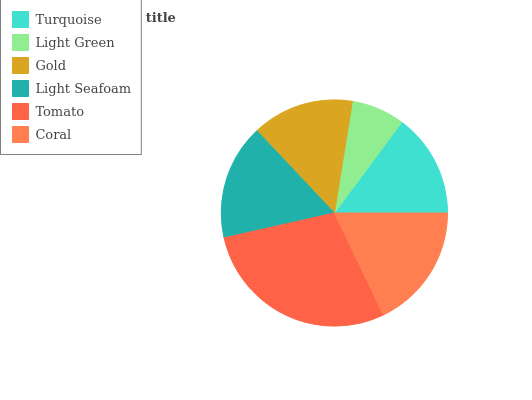Is Light Green the minimum?
Answer yes or no. Yes. Is Tomato the maximum?
Answer yes or no. Yes. Is Gold the minimum?
Answer yes or no. No. Is Gold the maximum?
Answer yes or no. No. Is Gold greater than Light Green?
Answer yes or no. Yes. Is Light Green less than Gold?
Answer yes or no. Yes. Is Light Green greater than Gold?
Answer yes or no. No. Is Gold less than Light Green?
Answer yes or no. No. Is Light Seafoam the high median?
Answer yes or no. Yes. Is Turquoise the low median?
Answer yes or no. Yes. Is Turquoise the high median?
Answer yes or no. No. Is Coral the low median?
Answer yes or no. No. 